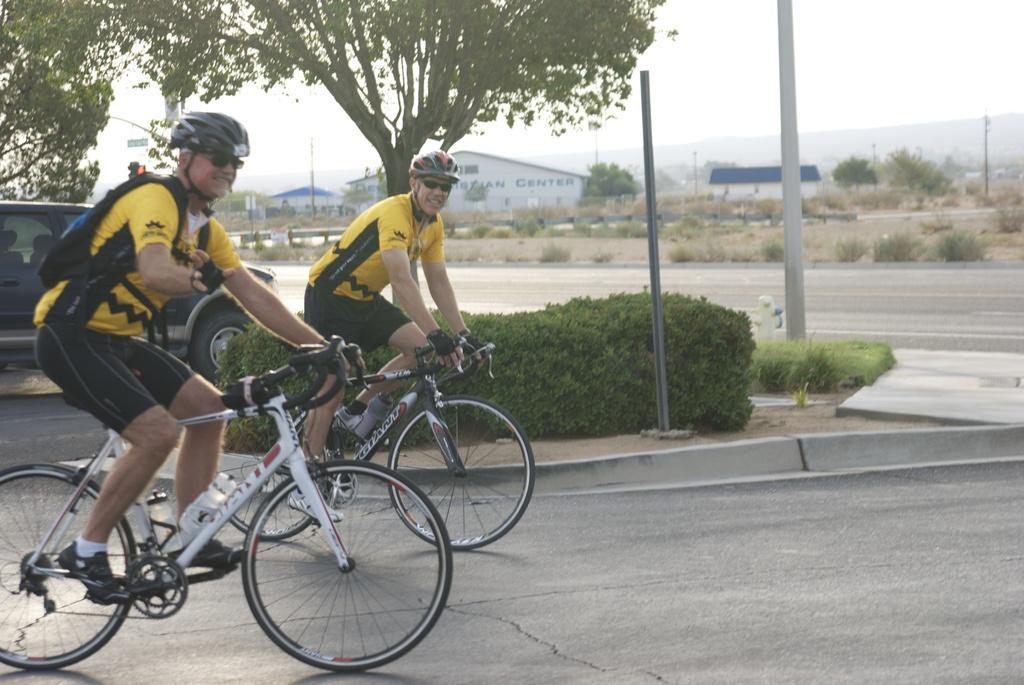Can you describe this image briefly? In this picture we can see two men wore goggles, helmets and riding bicycles on the road, trees, poles, buildings and in the background we can see the sky. 